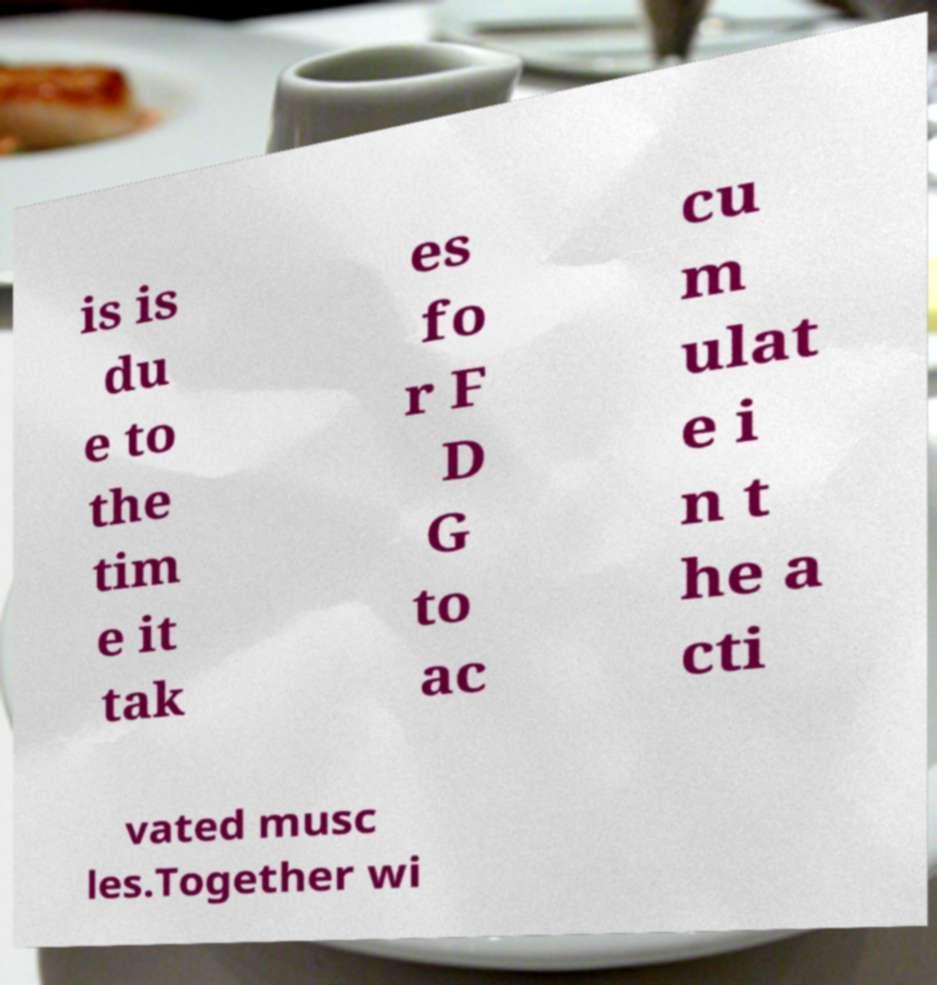Can you accurately transcribe the text from the provided image for me? is is du e to the tim e it tak es fo r F D G to ac cu m ulat e i n t he a cti vated musc les.Together wi 